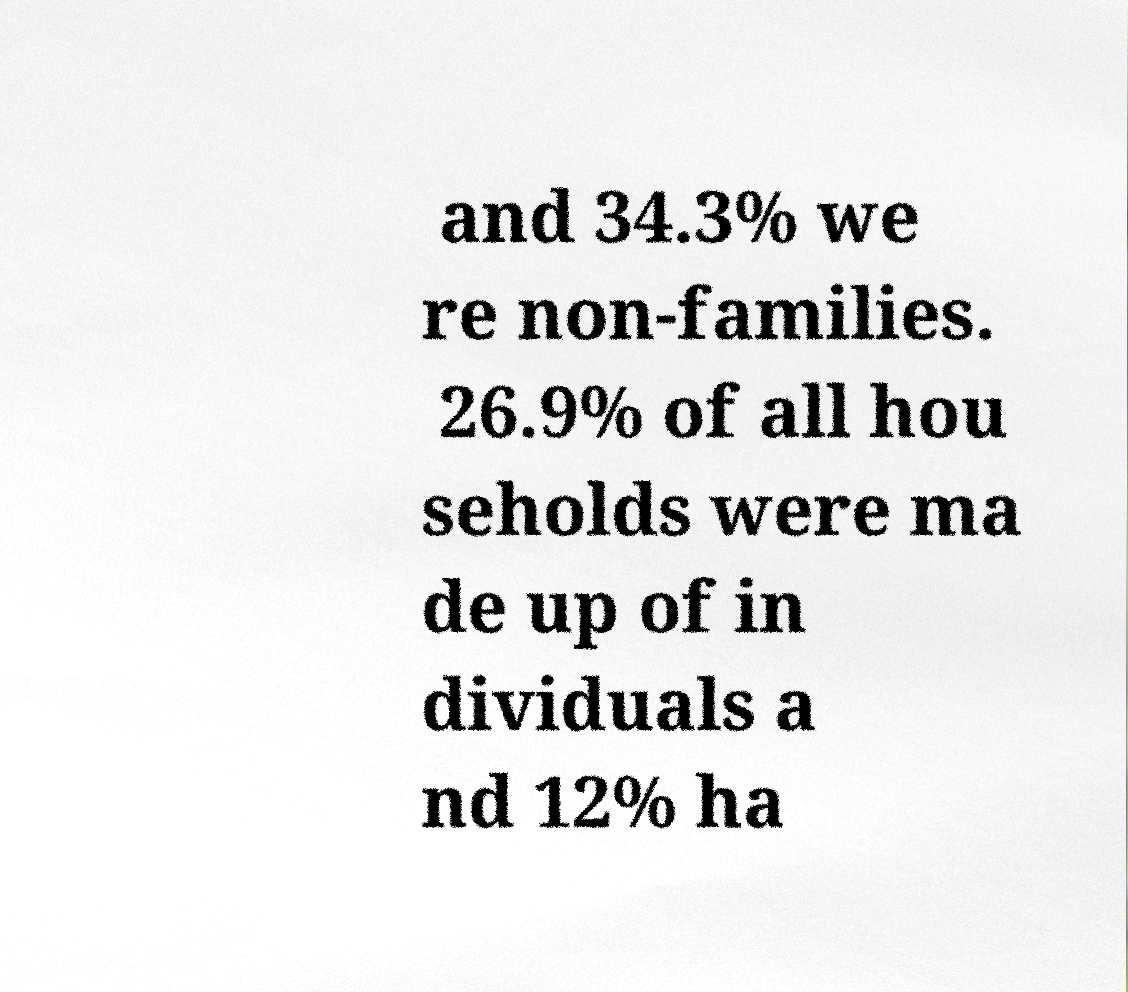I need the written content from this picture converted into text. Can you do that? and 34.3% we re non-families. 26.9% of all hou seholds were ma de up of in dividuals a nd 12% ha 